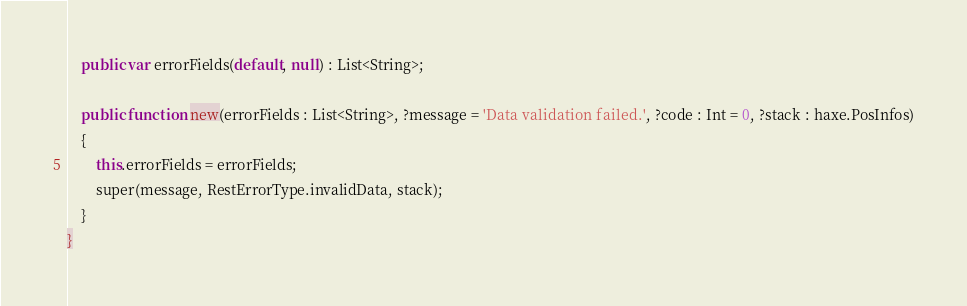Convert code to text. <code><loc_0><loc_0><loc_500><loc_500><_Haxe_>	public var errorFields(default, null) : List<String>;
	
	public function new(errorFields : List<String>, ?message = 'Data validation failed.', ?code : Int = 0, ?stack : haxe.PosInfos)
	{
		this.errorFields = errorFields;
		super(message, RestErrorType.invalidData, stack);
	}
}
</code> 